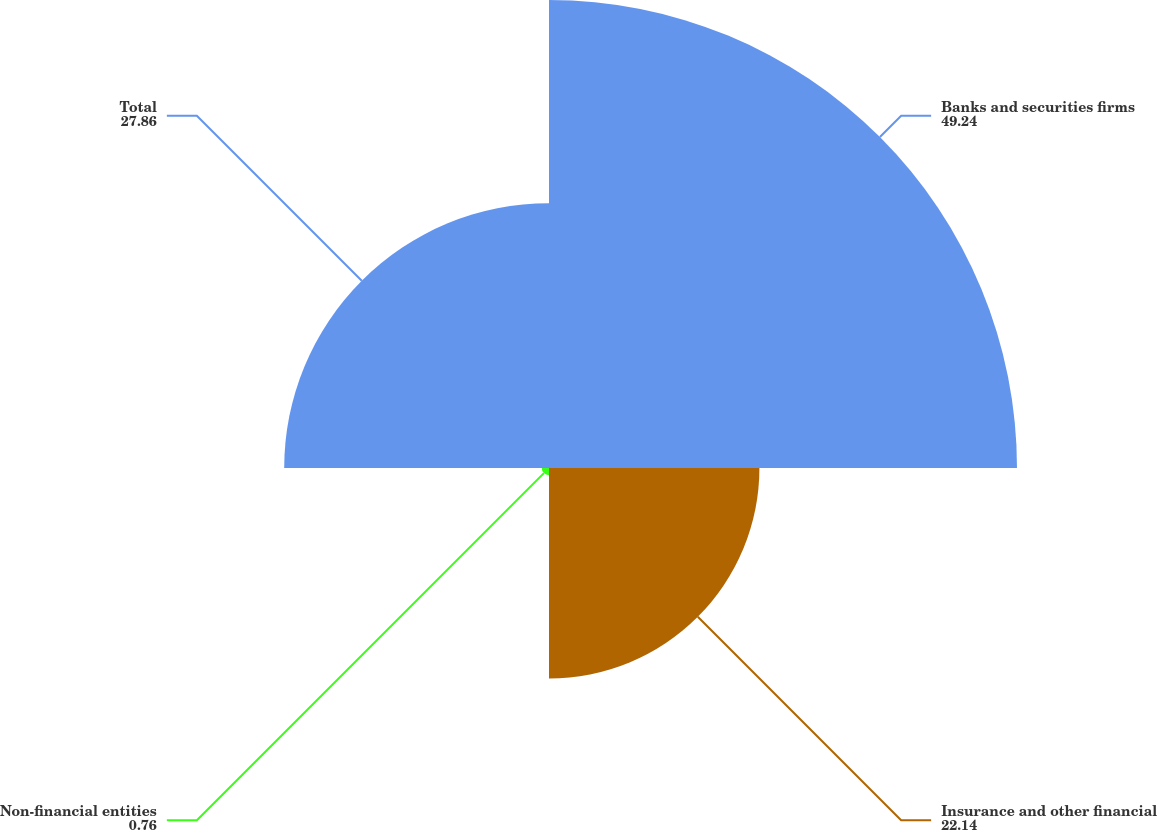Convert chart. <chart><loc_0><loc_0><loc_500><loc_500><pie_chart><fcel>Banks and securities firms<fcel>Insurance and other financial<fcel>Non-financial entities<fcel>Total<nl><fcel>49.24%<fcel>22.14%<fcel>0.76%<fcel>27.86%<nl></chart> 